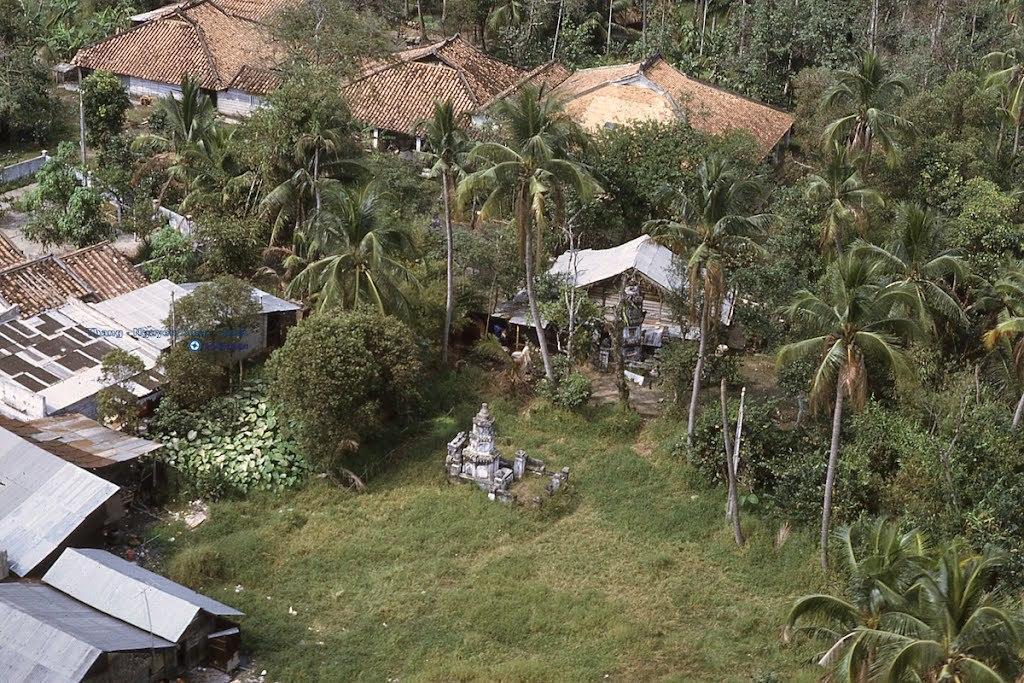Describe this image in one or two sentences. In the image there are a lot of houses and huts,around the houses there are many tall trees and grass. 